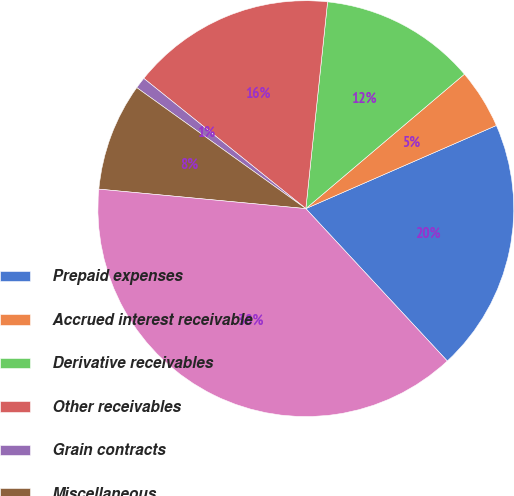<chart> <loc_0><loc_0><loc_500><loc_500><pie_chart><fcel>Prepaid expenses<fcel>Accrued interest receivable<fcel>Derivative receivables<fcel>Other receivables<fcel>Grain contracts<fcel>Miscellaneous<fcel>Total<nl><fcel>19.64%<fcel>4.64%<fcel>12.14%<fcel>15.89%<fcel>0.89%<fcel>8.39%<fcel>38.4%<nl></chart> 